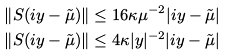<formula> <loc_0><loc_0><loc_500><loc_500>\left \| S ( i y - \tilde { \mu } ) \right \| & \leq 1 6 \kappa \mu ^ { - 2 } | i y - \tilde { \mu } | \\ \left \| S ( i y - \tilde { \mu } ) \right \| & \leq 4 \kappa | y | ^ { - 2 } | i y - \tilde { \mu } |</formula> 